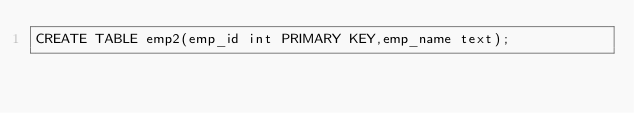Convert code to text. <code><loc_0><loc_0><loc_500><loc_500><_SQL_>CREATE TABLE emp2(emp_id int PRIMARY KEY,emp_name text);</code> 